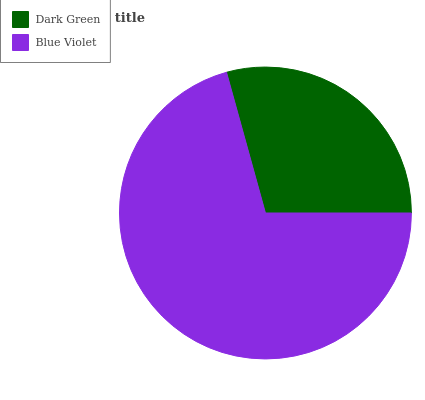Is Dark Green the minimum?
Answer yes or no. Yes. Is Blue Violet the maximum?
Answer yes or no. Yes. Is Blue Violet the minimum?
Answer yes or no. No. Is Blue Violet greater than Dark Green?
Answer yes or no. Yes. Is Dark Green less than Blue Violet?
Answer yes or no. Yes. Is Dark Green greater than Blue Violet?
Answer yes or no. No. Is Blue Violet less than Dark Green?
Answer yes or no. No. Is Blue Violet the high median?
Answer yes or no. Yes. Is Dark Green the low median?
Answer yes or no. Yes. Is Dark Green the high median?
Answer yes or no. No. Is Blue Violet the low median?
Answer yes or no. No. 